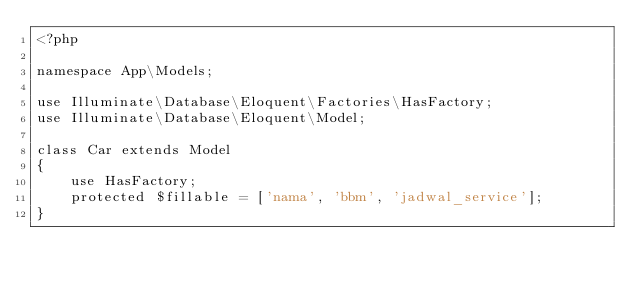Convert code to text. <code><loc_0><loc_0><loc_500><loc_500><_PHP_><?php

namespace App\Models;

use Illuminate\Database\Eloquent\Factories\HasFactory;
use Illuminate\Database\Eloquent\Model;

class Car extends Model
{
    use HasFactory;
    protected $fillable = ['nama', 'bbm', 'jadwal_service'];
}
</code> 